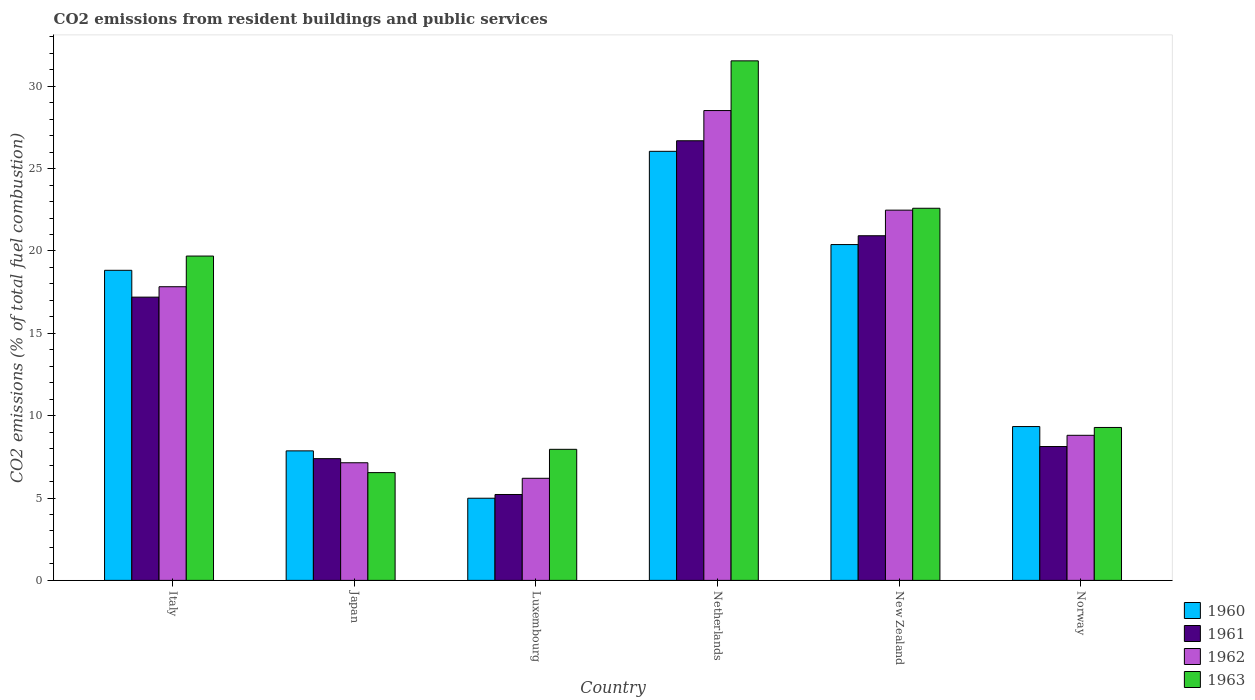How many groups of bars are there?
Provide a short and direct response. 6. Are the number of bars on each tick of the X-axis equal?
Your response must be concise. Yes. How many bars are there on the 6th tick from the left?
Make the answer very short. 4. What is the label of the 5th group of bars from the left?
Your answer should be compact. New Zealand. In how many cases, is the number of bars for a given country not equal to the number of legend labels?
Offer a terse response. 0. What is the total CO2 emitted in 1963 in Norway?
Keep it short and to the point. 9.28. Across all countries, what is the maximum total CO2 emitted in 1962?
Keep it short and to the point. 28.52. Across all countries, what is the minimum total CO2 emitted in 1960?
Provide a short and direct response. 4.99. What is the total total CO2 emitted in 1962 in the graph?
Ensure brevity in your answer.  90.98. What is the difference between the total CO2 emitted in 1962 in Netherlands and that in New Zealand?
Make the answer very short. 6.05. What is the difference between the total CO2 emitted in 1960 in Luxembourg and the total CO2 emitted in 1962 in Japan?
Provide a succinct answer. -2.15. What is the average total CO2 emitted in 1961 per country?
Provide a succinct answer. 14.26. What is the difference between the total CO2 emitted of/in 1961 and total CO2 emitted of/in 1963 in New Zealand?
Your answer should be very brief. -1.67. What is the ratio of the total CO2 emitted in 1960 in Italy to that in Japan?
Provide a succinct answer. 2.39. What is the difference between the highest and the second highest total CO2 emitted in 1960?
Offer a very short reply. 7.22. What is the difference between the highest and the lowest total CO2 emitted in 1960?
Offer a terse response. 21.06. Is it the case that in every country, the sum of the total CO2 emitted in 1961 and total CO2 emitted in 1960 is greater than the total CO2 emitted in 1962?
Give a very brief answer. Yes. How many bars are there?
Make the answer very short. 24. What is the difference between two consecutive major ticks on the Y-axis?
Your response must be concise. 5. Are the values on the major ticks of Y-axis written in scientific E-notation?
Offer a terse response. No. Where does the legend appear in the graph?
Your answer should be compact. Bottom right. How many legend labels are there?
Provide a succinct answer. 4. How are the legend labels stacked?
Your answer should be compact. Vertical. What is the title of the graph?
Keep it short and to the point. CO2 emissions from resident buildings and public services. Does "2003" appear as one of the legend labels in the graph?
Give a very brief answer. No. What is the label or title of the Y-axis?
Offer a terse response. CO2 emissions (% of total fuel combustion). What is the CO2 emissions (% of total fuel combustion) of 1960 in Italy?
Your response must be concise. 18.83. What is the CO2 emissions (% of total fuel combustion) in 1961 in Italy?
Your response must be concise. 17.2. What is the CO2 emissions (% of total fuel combustion) in 1962 in Italy?
Your answer should be very brief. 17.83. What is the CO2 emissions (% of total fuel combustion) of 1963 in Italy?
Make the answer very short. 19.69. What is the CO2 emissions (% of total fuel combustion) of 1960 in Japan?
Your answer should be very brief. 7.86. What is the CO2 emissions (% of total fuel combustion) of 1961 in Japan?
Your answer should be compact. 7.39. What is the CO2 emissions (% of total fuel combustion) of 1962 in Japan?
Make the answer very short. 7.14. What is the CO2 emissions (% of total fuel combustion) of 1963 in Japan?
Give a very brief answer. 6.54. What is the CO2 emissions (% of total fuel combustion) in 1960 in Luxembourg?
Provide a succinct answer. 4.99. What is the CO2 emissions (% of total fuel combustion) in 1961 in Luxembourg?
Provide a short and direct response. 5.21. What is the CO2 emissions (% of total fuel combustion) in 1962 in Luxembourg?
Make the answer very short. 6.2. What is the CO2 emissions (% of total fuel combustion) of 1963 in Luxembourg?
Your answer should be compact. 7.96. What is the CO2 emissions (% of total fuel combustion) of 1960 in Netherlands?
Provide a succinct answer. 26.05. What is the CO2 emissions (% of total fuel combustion) in 1961 in Netherlands?
Provide a succinct answer. 26.69. What is the CO2 emissions (% of total fuel combustion) in 1962 in Netherlands?
Offer a very short reply. 28.52. What is the CO2 emissions (% of total fuel combustion) in 1963 in Netherlands?
Make the answer very short. 31.54. What is the CO2 emissions (% of total fuel combustion) in 1960 in New Zealand?
Offer a terse response. 20.39. What is the CO2 emissions (% of total fuel combustion) in 1961 in New Zealand?
Provide a succinct answer. 20.92. What is the CO2 emissions (% of total fuel combustion) in 1962 in New Zealand?
Provide a short and direct response. 22.48. What is the CO2 emissions (% of total fuel combustion) of 1963 in New Zealand?
Offer a terse response. 22.59. What is the CO2 emissions (% of total fuel combustion) of 1960 in Norway?
Ensure brevity in your answer.  9.34. What is the CO2 emissions (% of total fuel combustion) of 1961 in Norway?
Keep it short and to the point. 8.13. What is the CO2 emissions (% of total fuel combustion) in 1962 in Norway?
Offer a terse response. 8.81. What is the CO2 emissions (% of total fuel combustion) in 1963 in Norway?
Provide a succinct answer. 9.28. Across all countries, what is the maximum CO2 emissions (% of total fuel combustion) in 1960?
Your answer should be very brief. 26.05. Across all countries, what is the maximum CO2 emissions (% of total fuel combustion) in 1961?
Provide a succinct answer. 26.69. Across all countries, what is the maximum CO2 emissions (% of total fuel combustion) of 1962?
Provide a short and direct response. 28.52. Across all countries, what is the maximum CO2 emissions (% of total fuel combustion) in 1963?
Provide a succinct answer. 31.54. Across all countries, what is the minimum CO2 emissions (% of total fuel combustion) in 1960?
Keep it short and to the point. 4.99. Across all countries, what is the minimum CO2 emissions (% of total fuel combustion) of 1961?
Provide a succinct answer. 5.21. Across all countries, what is the minimum CO2 emissions (% of total fuel combustion) in 1962?
Offer a very short reply. 6.2. Across all countries, what is the minimum CO2 emissions (% of total fuel combustion) in 1963?
Your response must be concise. 6.54. What is the total CO2 emissions (% of total fuel combustion) in 1960 in the graph?
Give a very brief answer. 87.45. What is the total CO2 emissions (% of total fuel combustion) of 1961 in the graph?
Your response must be concise. 85.54. What is the total CO2 emissions (% of total fuel combustion) in 1962 in the graph?
Offer a very short reply. 90.98. What is the total CO2 emissions (% of total fuel combustion) in 1963 in the graph?
Provide a short and direct response. 97.61. What is the difference between the CO2 emissions (% of total fuel combustion) in 1960 in Italy and that in Japan?
Make the answer very short. 10.96. What is the difference between the CO2 emissions (% of total fuel combustion) of 1961 in Italy and that in Japan?
Offer a terse response. 9.81. What is the difference between the CO2 emissions (% of total fuel combustion) of 1962 in Italy and that in Japan?
Keep it short and to the point. 10.69. What is the difference between the CO2 emissions (% of total fuel combustion) in 1963 in Italy and that in Japan?
Offer a terse response. 13.15. What is the difference between the CO2 emissions (% of total fuel combustion) of 1960 in Italy and that in Luxembourg?
Offer a terse response. 13.84. What is the difference between the CO2 emissions (% of total fuel combustion) of 1961 in Italy and that in Luxembourg?
Offer a very short reply. 11.98. What is the difference between the CO2 emissions (% of total fuel combustion) of 1962 in Italy and that in Luxembourg?
Provide a succinct answer. 11.63. What is the difference between the CO2 emissions (% of total fuel combustion) of 1963 in Italy and that in Luxembourg?
Keep it short and to the point. 11.73. What is the difference between the CO2 emissions (% of total fuel combustion) in 1960 in Italy and that in Netherlands?
Keep it short and to the point. -7.22. What is the difference between the CO2 emissions (% of total fuel combustion) in 1961 in Italy and that in Netherlands?
Make the answer very short. -9.49. What is the difference between the CO2 emissions (% of total fuel combustion) of 1962 in Italy and that in Netherlands?
Your answer should be compact. -10.7. What is the difference between the CO2 emissions (% of total fuel combustion) in 1963 in Italy and that in Netherlands?
Give a very brief answer. -11.85. What is the difference between the CO2 emissions (% of total fuel combustion) in 1960 in Italy and that in New Zealand?
Your answer should be very brief. -1.56. What is the difference between the CO2 emissions (% of total fuel combustion) in 1961 in Italy and that in New Zealand?
Make the answer very short. -3.73. What is the difference between the CO2 emissions (% of total fuel combustion) in 1962 in Italy and that in New Zealand?
Offer a very short reply. -4.65. What is the difference between the CO2 emissions (% of total fuel combustion) in 1963 in Italy and that in New Zealand?
Offer a very short reply. -2.9. What is the difference between the CO2 emissions (% of total fuel combustion) in 1960 in Italy and that in Norway?
Offer a very short reply. 9.49. What is the difference between the CO2 emissions (% of total fuel combustion) of 1961 in Italy and that in Norway?
Offer a terse response. 9.07. What is the difference between the CO2 emissions (% of total fuel combustion) of 1962 in Italy and that in Norway?
Provide a succinct answer. 9.02. What is the difference between the CO2 emissions (% of total fuel combustion) of 1963 in Italy and that in Norway?
Give a very brief answer. 10.41. What is the difference between the CO2 emissions (% of total fuel combustion) in 1960 in Japan and that in Luxembourg?
Your answer should be compact. 2.87. What is the difference between the CO2 emissions (% of total fuel combustion) in 1961 in Japan and that in Luxembourg?
Make the answer very short. 2.18. What is the difference between the CO2 emissions (% of total fuel combustion) of 1962 in Japan and that in Luxembourg?
Your response must be concise. 0.94. What is the difference between the CO2 emissions (% of total fuel combustion) in 1963 in Japan and that in Luxembourg?
Your answer should be very brief. -1.41. What is the difference between the CO2 emissions (% of total fuel combustion) in 1960 in Japan and that in Netherlands?
Give a very brief answer. -18.19. What is the difference between the CO2 emissions (% of total fuel combustion) in 1961 in Japan and that in Netherlands?
Your answer should be very brief. -19.3. What is the difference between the CO2 emissions (% of total fuel combustion) in 1962 in Japan and that in Netherlands?
Provide a short and direct response. -21.38. What is the difference between the CO2 emissions (% of total fuel combustion) of 1963 in Japan and that in Netherlands?
Your response must be concise. -25. What is the difference between the CO2 emissions (% of total fuel combustion) of 1960 in Japan and that in New Zealand?
Give a very brief answer. -12.53. What is the difference between the CO2 emissions (% of total fuel combustion) in 1961 in Japan and that in New Zealand?
Offer a terse response. -13.53. What is the difference between the CO2 emissions (% of total fuel combustion) of 1962 in Japan and that in New Zealand?
Keep it short and to the point. -15.34. What is the difference between the CO2 emissions (% of total fuel combustion) of 1963 in Japan and that in New Zealand?
Your answer should be compact. -16.05. What is the difference between the CO2 emissions (% of total fuel combustion) of 1960 in Japan and that in Norway?
Make the answer very short. -1.48. What is the difference between the CO2 emissions (% of total fuel combustion) of 1961 in Japan and that in Norway?
Your answer should be compact. -0.74. What is the difference between the CO2 emissions (% of total fuel combustion) of 1962 in Japan and that in Norway?
Give a very brief answer. -1.67. What is the difference between the CO2 emissions (% of total fuel combustion) of 1963 in Japan and that in Norway?
Provide a succinct answer. -2.74. What is the difference between the CO2 emissions (% of total fuel combustion) in 1960 in Luxembourg and that in Netherlands?
Make the answer very short. -21.06. What is the difference between the CO2 emissions (% of total fuel combustion) in 1961 in Luxembourg and that in Netherlands?
Your response must be concise. -21.48. What is the difference between the CO2 emissions (% of total fuel combustion) of 1962 in Luxembourg and that in Netherlands?
Your answer should be compact. -22.33. What is the difference between the CO2 emissions (% of total fuel combustion) of 1963 in Luxembourg and that in Netherlands?
Offer a very short reply. -23.58. What is the difference between the CO2 emissions (% of total fuel combustion) in 1960 in Luxembourg and that in New Zealand?
Make the answer very short. -15.4. What is the difference between the CO2 emissions (% of total fuel combustion) of 1961 in Luxembourg and that in New Zealand?
Your response must be concise. -15.71. What is the difference between the CO2 emissions (% of total fuel combustion) of 1962 in Luxembourg and that in New Zealand?
Provide a succinct answer. -16.28. What is the difference between the CO2 emissions (% of total fuel combustion) of 1963 in Luxembourg and that in New Zealand?
Your answer should be compact. -14.63. What is the difference between the CO2 emissions (% of total fuel combustion) in 1960 in Luxembourg and that in Norway?
Make the answer very short. -4.35. What is the difference between the CO2 emissions (% of total fuel combustion) of 1961 in Luxembourg and that in Norway?
Your answer should be very brief. -2.91. What is the difference between the CO2 emissions (% of total fuel combustion) in 1962 in Luxembourg and that in Norway?
Offer a terse response. -2.61. What is the difference between the CO2 emissions (% of total fuel combustion) of 1963 in Luxembourg and that in Norway?
Your answer should be compact. -1.33. What is the difference between the CO2 emissions (% of total fuel combustion) in 1960 in Netherlands and that in New Zealand?
Offer a very short reply. 5.66. What is the difference between the CO2 emissions (% of total fuel combustion) in 1961 in Netherlands and that in New Zealand?
Ensure brevity in your answer.  5.77. What is the difference between the CO2 emissions (% of total fuel combustion) of 1962 in Netherlands and that in New Zealand?
Your answer should be compact. 6.05. What is the difference between the CO2 emissions (% of total fuel combustion) in 1963 in Netherlands and that in New Zealand?
Offer a terse response. 8.95. What is the difference between the CO2 emissions (% of total fuel combustion) of 1960 in Netherlands and that in Norway?
Offer a terse response. 16.71. What is the difference between the CO2 emissions (% of total fuel combustion) in 1961 in Netherlands and that in Norway?
Your response must be concise. 18.56. What is the difference between the CO2 emissions (% of total fuel combustion) of 1962 in Netherlands and that in Norway?
Provide a short and direct response. 19.72. What is the difference between the CO2 emissions (% of total fuel combustion) of 1963 in Netherlands and that in Norway?
Your answer should be very brief. 22.26. What is the difference between the CO2 emissions (% of total fuel combustion) of 1960 in New Zealand and that in Norway?
Offer a terse response. 11.05. What is the difference between the CO2 emissions (% of total fuel combustion) of 1961 in New Zealand and that in Norway?
Your response must be concise. 12.8. What is the difference between the CO2 emissions (% of total fuel combustion) of 1962 in New Zealand and that in Norway?
Provide a short and direct response. 13.67. What is the difference between the CO2 emissions (% of total fuel combustion) of 1963 in New Zealand and that in Norway?
Provide a short and direct response. 13.31. What is the difference between the CO2 emissions (% of total fuel combustion) in 1960 in Italy and the CO2 emissions (% of total fuel combustion) in 1961 in Japan?
Keep it short and to the point. 11.43. What is the difference between the CO2 emissions (% of total fuel combustion) in 1960 in Italy and the CO2 emissions (% of total fuel combustion) in 1962 in Japan?
Your response must be concise. 11.68. What is the difference between the CO2 emissions (% of total fuel combustion) of 1960 in Italy and the CO2 emissions (% of total fuel combustion) of 1963 in Japan?
Your response must be concise. 12.28. What is the difference between the CO2 emissions (% of total fuel combustion) in 1961 in Italy and the CO2 emissions (% of total fuel combustion) in 1962 in Japan?
Provide a succinct answer. 10.05. What is the difference between the CO2 emissions (% of total fuel combustion) in 1961 in Italy and the CO2 emissions (% of total fuel combustion) in 1963 in Japan?
Offer a very short reply. 10.65. What is the difference between the CO2 emissions (% of total fuel combustion) in 1962 in Italy and the CO2 emissions (% of total fuel combustion) in 1963 in Japan?
Your answer should be very brief. 11.29. What is the difference between the CO2 emissions (% of total fuel combustion) in 1960 in Italy and the CO2 emissions (% of total fuel combustion) in 1961 in Luxembourg?
Keep it short and to the point. 13.61. What is the difference between the CO2 emissions (% of total fuel combustion) in 1960 in Italy and the CO2 emissions (% of total fuel combustion) in 1962 in Luxembourg?
Give a very brief answer. 12.63. What is the difference between the CO2 emissions (% of total fuel combustion) in 1960 in Italy and the CO2 emissions (% of total fuel combustion) in 1963 in Luxembourg?
Offer a terse response. 10.87. What is the difference between the CO2 emissions (% of total fuel combustion) of 1961 in Italy and the CO2 emissions (% of total fuel combustion) of 1962 in Luxembourg?
Ensure brevity in your answer.  11. What is the difference between the CO2 emissions (% of total fuel combustion) of 1961 in Italy and the CO2 emissions (% of total fuel combustion) of 1963 in Luxembourg?
Offer a very short reply. 9.24. What is the difference between the CO2 emissions (% of total fuel combustion) in 1962 in Italy and the CO2 emissions (% of total fuel combustion) in 1963 in Luxembourg?
Ensure brevity in your answer.  9.87. What is the difference between the CO2 emissions (% of total fuel combustion) of 1960 in Italy and the CO2 emissions (% of total fuel combustion) of 1961 in Netherlands?
Your answer should be very brief. -7.86. What is the difference between the CO2 emissions (% of total fuel combustion) in 1960 in Italy and the CO2 emissions (% of total fuel combustion) in 1962 in Netherlands?
Make the answer very short. -9.7. What is the difference between the CO2 emissions (% of total fuel combustion) of 1960 in Italy and the CO2 emissions (% of total fuel combustion) of 1963 in Netherlands?
Offer a terse response. -12.72. What is the difference between the CO2 emissions (% of total fuel combustion) of 1961 in Italy and the CO2 emissions (% of total fuel combustion) of 1962 in Netherlands?
Provide a short and direct response. -11.33. What is the difference between the CO2 emissions (% of total fuel combustion) of 1961 in Italy and the CO2 emissions (% of total fuel combustion) of 1963 in Netherlands?
Offer a terse response. -14.35. What is the difference between the CO2 emissions (% of total fuel combustion) in 1962 in Italy and the CO2 emissions (% of total fuel combustion) in 1963 in Netherlands?
Offer a very short reply. -13.71. What is the difference between the CO2 emissions (% of total fuel combustion) of 1960 in Italy and the CO2 emissions (% of total fuel combustion) of 1961 in New Zealand?
Your answer should be very brief. -2.1. What is the difference between the CO2 emissions (% of total fuel combustion) in 1960 in Italy and the CO2 emissions (% of total fuel combustion) in 1962 in New Zealand?
Provide a succinct answer. -3.65. What is the difference between the CO2 emissions (% of total fuel combustion) in 1960 in Italy and the CO2 emissions (% of total fuel combustion) in 1963 in New Zealand?
Offer a terse response. -3.77. What is the difference between the CO2 emissions (% of total fuel combustion) in 1961 in Italy and the CO2 emissions (% of total fuel combustion) in 1962 in New Zealand?
Your answer should be very brief. -5.28. What is the difference between the CO2 emissions (% of total fuel combustion) in 1961 in Italy and the CO2 emissions (% of total fuel combustion) in 1963 in New Zealand?
Offer a very short reply. -5.4. What is the difference between the CO2 emissions (% of total fuel combustion) in 1962 in Italy and the CO2 emissions (% of total fuel combustion) in 1963 in New Zealand?
Keep it short and to the point. -4.76. What is the difference between the CO2 emissions (% of total fuel combustion) of 1960 in Italy and the CO2 emissions (% of total fuel combustion) of 1961 in Norway?
Your answer should be very brief. 10.7. What is the difference between the CO2 emissions (% of total fuel combustion) in 1960 in Italy and the CO2 emissions (% of total fuel combustion) in 1962 in Norway?
Provide a succinct answer. 10.02. What is the difference between the CO2 emissions (% of total fuel combustion) of 1960 in Italy and the CO2 emissions (% of total fuel combustion) of 1963 in Norway?
Offer a terse response. 9.54. What is the difference between the CO2 emissions (% of total fuel combustion) in 1961 in Italy and the CO2 emissions (% of total fuel combustion) in 1962 in Norway?
Provide a succinct answer. 8.39. What is the difference between the CO2 emissions (% of total fuel combustion) of 1961 in Italy and the CO2 emissions (% of total fuel combustion) of 1963 in Norway?
Provide a short and direct response. 7.91. What is the difference between the CO2 emissions (% of total fuel combustion) of 1962 in Italy and the CO2 emissions (% of total fuel combustion) of 1963 in Norway?
Your answer should be compact. 8.54. What is the difference between the CO2 emissions (% of total fuel combustion) of 1960 in Japan and the CO2 emissions (% of total fuel combustion) of 1961 in Luxembourg?
Your answer should be very brief. 2.65. What is the difference between the CO2 emissions (% of total fuel combustion) of 1960 in Japan and the CO2 emissions (% of total fuel combustion) of 1962 in Luxembourg?
Your answer should be very brief. 1.66. What is the difference between the CO2 emissions (% of total fuel combustion) of 1960 in Japan and the CO2 emissions (% of total fuel combustion) of 1963 in Luxembourg?
Your response must be concise. -0.09. What is the difference between the CO2 emissions (% of total fuel combustion) of 1961 in Japan and the CO2 emissions (% of total fuel combustion) of 1962 in Luxembourg?
Your response must be concise. 1.19. What is the difference between the CO2 emissions (% of total fuel combustion) in 1961 in Japan and the CO2 emissions (% of total fuel combustion) in 1963 in Luxembourg?
Make the answer very short. -0.57. What is the difference between the CO2 emissions (% of total fuel combustion) of 1962 in Japan and the CO2 emissions (% of total fuel combustion) of 1963 in Luxembourg?
Keep it short and to the point. -0.82. What is the difference between the CO2 emissions (% of total fuel combustion) in 1960 in Japan and the CO2 emissions (% of total fuel combustion) in 1961 in Netherlands?
Offer a very short reply. -18.83. What is the difference between the CO2 emissions (% of total fuel combustion) of 1960 in Japan and the CO2 emissions (% of total fuel combustion) of 1962 in Netherlands?
Keep it short and to the point. -20.66. What is the difference between the CO2 emissions (% of total fuel combustion) in 1960 in Japan and the CO2 emissions (% of total fuel combustion) in 1963 in Netherlands?
Provide a succinct answer. -23.68. What is the difference between the CO2 emissions (% of total fuel combustion) in 1961 in Japan and the CO2 emissions (% of total fuel combustion) in 1962 in Netherlands?
Make the answer very short. -21.13. What is the difference between the CO2 emissions (% of total fuel combustion) in 1961 in Japan and the CO2 emissions (% of total fuel combustion) in 1963 in Netherlands?
Your answer should be compact. -24.15. What is the difference between the CO2 emissions (% of total fuel combustion) in 1962 in Japan and the CO2 emissions (% of total fuel combustion) in 1963 in Netherlands?
Your response must be concise. -24.4. What is the difference between the CO2 emissions (% of total fuel combustion) in 1960 in Japan and the CO2 emissions (% of total fuel combustion) in 1961 in New Zealand?
Offer a terse response. -13.06. What is the difference between the CO2 emissions (% of total fuel combustion) of 1960 in Japan and the CO2 emissions (% of total fuel combustion) of 1962 in New Zealand?
Your answer should be compact. -14.61. What is the difference between the CO2 emissions (% of total fuel combustion) of 1960 in Japan and the CO2 emissions (% of total fuel combustion) of 1963 in New Zealand?
Provide a succinct answer. -14.73. What is the difference between the CO2 emissions (% of total fuel combustion) of 1961 in Japan and the CO2 emissions (% of total fuel combustion) of 1962 in New Zealand?
Give a very brief answer. -15.09. What is the difference between the CO2 emissions (% of total fuel combustion) of 1961 in Japan and the CO2 emissions (% of total fuel combustion) of 1963 in New Zealand?
Provide a short and direct response. -15.2. What is the difference between the CO2 emissions (% of total fuel combustion) of 1962 in Japan and the CO2 emissions (% of total fuel combustion) of 1963 in New Zealand?
Keep it short and to the point. -15.45. What is the difference between the CO2 emissions (% of total fuel combustion) in 1960 in Japan and the CO2 emissions (% of total fuel combustion) in 1961 in Norway?
Your answer should be compact. -0.26. What is the difference between the CO2 emissions (% of total fuel combustion) in 1960 in Japan and the CO2 emissions (% of total fuel combustion) in 1962 in Norway?
Provide a succinct answer. -0.94. What is the difference between the CO2 emissions (% of total fuel combustion) of 1960 in Japan and the CO2 emissions (% of total fuel combustion) of 1963 in Norway?
Make the answer very short. -1.42. What is the difference between the CO2 emissions (% of total fuel combustion) of 1961 in Japan and the CO2 emissions (% of total fuel combustion) of 1962 in Norway?
Ensure brevity in your answer.  -1.42. What is the difference between the CO2 emissions (% of total fuel combustion) of 1961 in Japan and the CO2 emissions (% of total fuel combustion) of 1963 in Norway?
Keep it short and to the point. -1.89. What is the difference between the CO2 emissions (% of total fuel combustion) of 1962 in Japan and the CO2 emissions (% of total fuel combustion) of 1963 in Norway?
Provide a short and direct response. -2.14. What is the difference between the CO2 emissions (% of total fuel combustion) in 1960 in Luxembourg and the CO2 emissions (% of total fuel combustion) in 1961 in Netherlands?
Provide a succinct answer. -21.7. What is the difference between the CO2 emissions (% of total fuel combustion) of 1960 in Luxembourg and the CO2 emissions (% of total fuel combustion) of 1962 in Netherlands?
Offer a very short reply. -23.54. What is the difference between the CO2 emissions (% of total fuel combustion) of 1960 in Luxembourg and the CO2 emissions (% of total fuel combustion) of 1963 in Netherlands?
Offer a terse response. -26.55. What is the difference between the CO2 emissions (% of total fuel combustion) in 1961 in Luxembourg and the CO2 emissions (% of total fuel combustion) in 1962 in Netherlands?
Your answer should be very brief. -23.31. What is the difference between the CO2 emissions (% of total fuel combustion) of 1961 in Luxembourg and the CO2 emissions (% of total fuel combustion) of 1963 in Netherlands?
Ensure brevity in your answer.  -26.33. What is the difference between the CO2 emissions (% of total fuel combustion) in 1962 in Luxembourg and the CO2 emissions (% of total fuel combustion) in 1963 in Netherlands?
Give a very brief answer. -25.34. What is the difference between the CO2 emissions (% of total fuel combustion) of 1960 in Luxembourg and the CO2 emissions (% of total fuel combustion) of 1961 in New Zealand?
Offer a terse response. -15.94. What is the difference between the CO2 emissions (% of total fuel combustion) in 1960 in Luxembourg and the CO2 emissions (% of total fuel combustion) in 1962 in New Zealand?
Your answer should be very brief. -17.49. What is the difference between the CO2 emissions (% of total fuel combustion) of 1960 in Luxembourg and the CO2 emissions (% of total fuel combustion) of 1963 in New Zealand?
Your response must be concise. -17.6. What is the difference between the CO2 emissions (% of total fuel combustion) of 1961 in Luxembourg and the CO2 emissions (% of total fuel combustion) of 1962 in New Zealand?
Offer a very short reply. -17.26. What is the difference between the CO2 emissions (% of total fuel combustion) of 1961 in Luxembourg and the CO2 emissions (% of total fuel combustion) of 1963 in New Zealand?
Make the answer very short. -17.38. What is the difference between the CO2 emissions (% of total fuel combustion) in 1962 in Luxembourg and the CO2 emissions (% of total fuel combustion) in 1963 in New Zealand?
Keep it short and to the point. -16.39. What is the difference between the CO2 emissions (% of total fuel combustion) of 1960 in Luxembourg and the CO2 emissions (% of total fuel combustion) of 1961 in Norway?
Provide a short and direct response. -3.14. What is the difference between the CO2 emissions (% of total fuel combustion) of 1960 in Luxembourg and the CO2 emissions (% of total fuel combustion) of 1962 in Norway?
Ensure brevity in your answer.  -3.82. What is the difference between the CO2 emissions (% of total fuel combustion) in 1960 in Luxembourg and the CO2 emissions (% of total fuel combustion) in 1963 in Norway?
Ensure brevity in your answer.  -4.3. What is the difference between the CO2 emissions (% of total fuel combustion) in 1961 in Luxembourg and the CO2 emissions (% of total fuel combustion) in 1962 in Norway?
Offer a very short reply. -3.59. What is the difference between the CO2 emissions (% of total fuel combustion) of 1961 in Luxembourg and the CO2 emissions (% of total fuel combustion) of 1963 in Norway?
Your answer should be compact. -4.07. What is the difference between the CO2 emissions (% of total fuel combustion) in 1962 in Luxembourg and the CO2 emissions (% of total fuel combustion) in 1963 in Norway?
Ensure brevity in your answer.  -3.09. What is the difference between the CO2 emissions (% of total fuel combustion) in 1960 in Netherlands and the CO2 emissions (% of total fuel combustion) in 1961 in New Zealand?
Your response must be concise. 5.13. What is the difference between the CO2 emissions (% of total fuel combustion) in 1960 in Netherlands and the CO2 emissions (% of total fuel combustion) in 1962 in New Zealand?
Offer a terse response. 3.57. What is the difference between the CO2 emissions (% of total fuel combustion) of 1960 in Netherlands and the CO2 emissions (% of total fuel combustion) of 1963 in New Zealand?
Provide a short and direct response. 3.46. What is the difference between the CO2 emissions (% of total fuel combustion) of 1961 in Netherlands and the CO2 emissions (% of total fuel combustion) of 1962 in New Zealand?
Give a very brief answer. 4.21. What is the difference between the CO2 emissions (% of total fuel combustion) in 1961 in Netherlands and the CO2 emissions (% of total fuel combustion) in 1963 in New Zealand?
Provide a short and direct response. 4.1. What is the difference between the CO2 emissions (% of total fuel combustion) in 1962 in Netherlands and the CO2 emissions (% of total fuel combustion) in 1963 in New Zealand?
Ensure brevity in your answer.  5.93. What is the difference between the CO2 emissions (% of total fuel combustion) of 1960 in Netherlands and the CO2 emissions (% of total fuel combustion) of 1961 in Norway?
Your response must be concise. 17.92. What is the difference between the CO2 emissions (% of total fuel combustion) of 1960 in Netherlands and the CO2 emissions (% of total fuel combustion) of 1962 in Norway?
Offer a terse response. 17.24. What is the difference between the CO2 emissions (% of total fuel combustion) in 1960 in Netherlands and the CO2 emissions (% of total fuel combustion) in 1963 in Norway?
Offer a terse response. 16.76. What is the difference between the CO2 emissions (% of total fuel combustion) in 1961 in Netherlands and the CO2 emissions (% of total fuel combustion) in 1962 in Norway?
Give a very brief answer. 17.88. What is the difference between the CO2 emissions (% of total fuel combustion) of 1961 in Netherlands and the CO2 emissions (% of total fuel combustion) of 1963 in Norway?
Your answer should be compact. 17.41. What is the difference between the CO2 emissions (% of total fuel combustion) in 1962 in Netherlands and the CO2 emissions (% of total fuel combustion) in 1963 in Norway?
Offer a very short reply. 19.24. What is the difference between the CO2 emissions (% of total fuel combustion) of 1960 in New Zealand and the CO2 emissions (% of total fuel combustion) of 1961 in Norway?
Keep it short and to the point. 12.26. What is the difference between the CO2 emissions (% of total fuel combustion) in 1960 in New Zealand and the CO2 emissions (% of total fuel combustion) in 1962 in Norway?
Provide a short and direct response. 11.58. What is the difference between the CO2 emissions (% of total fuel combustion) in 1960 in New Zealand and the CO2 emissions (% of total fuel combustion) in 1963 in Norway?
Your answer should be very brief. 11.1. What is the difference between the CO2 emissions (% of total fuel combustion) in 1961 in New Zealand and the CO2 emissions (% of total fuel combustion) in 1962 in Norway?
Offer a very short reply. 12.12. What is the difference between the CO2 emissions (% of total fuel combustion) of 1961 in New Zealand and the CO2 emissions (% of total fuel combustion) of 1963 in Norway?
Your answer should be very brief. 11.64. What is the difference between the CO2 emissions (% of total fuel combustion) of 1962 in New Zealand and the CO2 emissions (% of total fuel combustion) of 1963 in Norway?
Keep it short and to the point. 13.19. What is the average CO2 emissions (% of total fuel combustion) of 1960 per country?
Make the answer very short. 14.58. What is the average CO2 emissions (% of total fuel combustion) of 1961 per country?
Your response must be concise. 14.26. What is the average CO2 emissions (% of total fuel combustion) of 1962 per country?
Provide a short and direct response. 15.16. What is the average CO2 emissions (% of total fuel combustion) in 1963 per country?
Offer a very short reply. 16.27. What is the difference between the CO2 emissions (% of total fuel combustion) in 1960 and CO2 emissions (% of total fuel combustion) in 1961 in Italy?
Your answer should be very brief. 1.63. What is the difference between the CO2 emissions (% of total fuel combustion) of 1960 and CO2 emissions (% of total fuel combustion) of 1962 in Italy?
Provide a succinct answer. 1. What is the difference between the CO2 emissions (% of total fuel combustion) in 1960 and CO2 emissions (% of total fuel combustion) in 1963 in Italy?
Give a very brief answer. -0.87. What is the difference between the CO2 emissions (% of total fuel combustion) of 1961 and CO2 emissions (% of total fuel combustion) of 1962 in Italy?
Your response must be concise. -0.63. What is the difference between the CO2 emissions (% of total fuel combustion) in 1961 and CO2 emissions (% of total fuel combustion) in 1963 in Italy?
Ensure brevity in your answer.  -2.49. What is the difference between the CO2 emissions (% of total fuel combustion) in 1962 and CO2 emissions (% of total fuel combustion) in 1963 in Italy?
Offer a terse response. -1.86. What is the difference between the CO2 emissions (% of total fuel combustion) of 1960 and CO2 emissions (% of total fuel combustion) of 1961 in Japan?
Keep it short and to the point. 0.47. What is the difference between the CO2 emissions (% of total fuel combustion) in 1960 and CO2 emissions (% of total fuel combustion) in 1962 in Japan?
Give a very brief answer. 0.72. What is the difference between the CO2 emissions (% of total fuel combustion) in 1960 and CO2 emissions (% of total fuel combustion) in 1963 in Japan?
Give a very brief answer. 1.32. What is the difference between the CO2 emissions (% of total fuel combustion) in 1961 and CO2 emissions (% of total fuel combustion) in 1962 in Japan?
Your response must be concise. 0.25. What is the difference between the CO2 emissions (% of total fuel combustion) in 1961 and CO2 emissions (% of total fuel combustion) in 1963 in Japan?
Your response must be concise. 0.85. What is the difference between the CO2 emissions (% of total fuel combustion) of 1962 and CO2 emissions (% of total fuel combustion) of 1963 in Japan?
Keep it short and to the point. 0.6. What is the difference between the CO2 emissions (% of total fuel combustion) of 1960 and CO2 emissions (% of total fuel combustion) of 1961 in Luxembourg?
Keep it short and to the point. -0.23. What is the difference between the CO2 emissions (% of total fuel combustion) of 1960 and CO2 emissions (% of total fuel combustion) of 1962 in Luxembourg?
Provide a short and direct response. -1.21. What is the difference between the CO2 emissions (% of total fuel combustion) in 1960 and CO2 emissions (% of total fuel combustion) in 1963 in Luxembourg?
Ensure brevity in your answer.  -2.97. What is the difference between the CO2 emissions (% of total fuel combustion) in 1961 and CO2 emissions (% of total fuel combustion) in 1962 in Luxembourg?
Provide a short and direct response. -0.98. What is the difference between the CO2 emissions (% of total fuel combustion) in 1961 and CO2 emissions (% of total fuel combustion) in 1963 in Luxembourg?
Provide a short and direct response. -2.74. What is the difference between the CO2 emissions (% of total fuel combustion) of 1962 and CO2 emissions (% of total fuel combustion) of 1963 in Luxembourg?
Offer a very short reply. -1.76. What is the difference between the CO2 emissions (% of total fuel combustion) of 1960 and CO2 emissions (% of total fuel combustion) of 1961 in Netherlands?
Your response must be concise. -0.64. What is the difference between the CO2 emissions (% of total fuel combustion) of 1960 and CO2 emissions (% of total fuel combustion) of 1962 in Netherlands?
Your answer should be very brief. -2.47. What is the difference between the CO2 emissions (% of total fuel combustion) of 1960 and CO2 emissions (% of total fuel combustion) of 1963 in Netherlands?
Make the answer very short. -5.49. What is the difference between the CO2 emissions (% of total fuel combustion) in 1961 and CO2 emissions (% of total fuel combustion) in 1962 in Netherlands?
Give a very brief answer. -1.83. What is the difference between the CO2 emissions (% of total fuel combustion) of 1961 and CO2 emissions (% of total fuel combustion) of 1963 in Netherlands?
Your response must be concise. -4.85. What is the difference between the CO2 emissions (% of total fuel combustion) of 1962 and CO2 emissions (% of total fuel combustion) of 1963 in Netherlands?
Your answer should be very brief. -3.02. What is the difference between the CO2 emissions (% of total fuel combustion) in 1960 and CO2 emissions (% of total fuel combustion) in 1961 in New Zealand?
Give a very brief answer. -0.54. What is the difference between the CO2 emissions (% of total fuel combustion) in 1960 and CO2 emissions (% of total fuel combustion) in 1962 in New Zealand?
Your answer should be very brief. -2.09. What is the difference between the CO2 emissions (% of total fuel combustion) in 1960 and CO2 emissions (% of total fuel combustion) in 1963 in New Zealand?
Keep it short and to the point. -2.2. What is the difference between the CO2 emissions (% of total fuel combustion) of 1961 and CO2 emissions (% of total fuel combustion) of 1962 in New Zealand?
Give a very brief answer. -1.55. What is the difference between the CO2 emissions (% of total fuel combustion) of 1961 and CO2 emissions (% of total fuel combustion) of 1963 in New Zealand?
Ensure brevity in your answer.  -1.67. What is the difference between the CO2 emissions (% of total fuel combustion) of 1962 and CO2 emissions (% of total fuel combustion) of 1963 in New Zealand?
Give a very brief answer. -0.12. What is the difference between the CO2 emissions (% of total fuel combustion) in 1960 and CO2 emissions (% of total fuel combustion) in 1961 in Norway?
Your answer should be compact. 1.21. What is the difference between the CO2 emissions (% of total fuel combustion) in 1960 and CO2 emissions (% of total fuel combustion) in 1962 in Norway?
Your response must be concise. 0.53. What is the difference between the CO2 emissions (% of total fuel combustion) of 1960 and CO2 emissions (% of total fuel combustion) of 1963 in Norway?
Your response must be concise. 0.05. What is the difference between the CO2 emissions (% of total fuel combustion) in 1961 and CO2 emissions (% of total fuel combustion) in 1962 in Norway?
Your answer should be compact. -0.68. What is the difference between the CO2 emissions (% of total fuel combustion) in 1961 and CO2 emissions (% of total fuel combustion) in 1963 in Norway?
Your answer should be very brief. -1.16. What is the difference between the CO2 emissions (% of total fuel combustion) of 1962 and CO2 emissions (% of total fuel combustion) of 1963 in Norway?
Provide a succinct answer. -0.48. What is the ratio of the CO2 emissions (% of total fuel combustion) of 1960 in Italy to that in Japan?
Offer a very short reply. 2.39. What is the ratio of the CO2 emissions (% of total fuel combustion) of 1961 in Italy to that in Japan?
Provide a short and direct response. 2.33. What is the ratio of the CO2 emissions (% of total fuel combustion) of 1962 in Italy to that in Japan?
Give a very brief answer. 2.5. What is the ratio of the CO2 emissions (% of total fuel combustion) of 1963 in Italy to that in Japan?
Provide a short and direct response. 3.01. What is the ratio of the CO2 emissions (% of total fuel combustion) in 1960 in Italy to that in Luxembourg?
Ensure brevity in your answer.  3.77. What is the ratio of the CO2 emissions (% of total fuel combustion) in 1961 in Italy to that in Luxembourg?
Your answer should be compact. 3.3. What is the ratio of the CO2 emissions (% of total fuel combustion) in 1962 in Italy to that in Luxembourg?
Your answer should be very brief. 2.88. What is the ratio of the CO2 emissions (% of total fuel combustion) of 1963 in Italy to that in Luxembourg?
Your answer should be compact. 2.47. What is the ratio of the CO2 emissions (% of total fuel combustion) of 1960 in Italy to that in Netherlands?
Your answer should be very brief. 0.72. What is the ratio of the CO2 emissions (% of total fuel combustion) of 1961 in Italy to that in Netherlands?
Offer a terse response. 0.64. What is the ratio of the CO2 emissions (% of total fuel combustion) of 1963 in Italy to that in Netherlands?
Provide a succinct answer. 0.62. What is the ratio of the CO2 emissions (% of total fuel combustion) in 1960 in Italy to that in New Zealand?
Make the answer very short. 0.92. What is the ratio of the CO2 emissions (% of total fuel combustion) of 1961 in Italy to that in New Zealand?
Ensure brevity in your answer.  0.82. What is the ratio of the CO2 emissions (% of total fuel combustion) of 1962 in Italy to that in New Zealand?
Ensure brevity in your answer.  0.79. What is the ratio of the CO2 emissions (% of total fuel combustion) of 1963 in Italy to that in New Zealand?
Offer a very short reply. 0.87. What is the ratio of the CO2 emissions (% of total fuel combustion) of 1960 in Italy to that in Norway?
Make the answer very short. 2.02. What is the ratio of the CO2 emissions (% of total fuel combustion) of 1961 in Italy to that in Norway?
Offer a very short reply. 2.12. What is the ratio of the CO2 emissions (% of total fuel combustion) in 1962 in Italy to that in Norway?
Keep it short and to the point. 2.02. What is the ratio of the CO2 emissions (% of total fuel combustion) in 1963 in Italy to that in Norway?
Your response must be concise. 2.12. What is the ratio of the CO2 emissions (% of total fuel combustion) of 1960 in Japan to that in Luxembourg?
Your answer should be very brief. 1.58. What is the ratio of the CO2 emissions (% of total fuel combustion) in 1961 in Japan to that in Luxembourg?
Make the answer very short. 1.42. What is the ratio of the CO2 emissions (% of total fuel combustion) in 1962 in Japan to that in Luxembourg?
Keep it short and to the point. 1.15. What is the ratio of the CO2 emissions (% of total fuel combustion) in 1963 in Japan to that in Luxembourg?
Give a very brief answer. 0.82. What is the ratio of the CO2 emissions (% of total fuel combustion) of 1960 in Japan to that in Netherlands?
Your answer should be compact. 0.3. What is the ratio of the CO2 emissions (% of total fuel combustion) of 1961 in Japan to that in Netherlands?
Your response must be concise. 0.28. What is the ratio of the CO2 emissions (% of total fuel combustion) in 1962 in Japan to that in Netherlands?
Ensure brevity in your answer.  0.25. What is the ratio of the CO2 emissions (% of total fuel combustion) of 1963 in Japan to that in Netherlands?
Your response must be concise. 0.21. What is the ratio of the CO2 emissions (% of total fuel combustion) in 1960 in Japan to that in New Zealand?
Your response must be concise. 0.39. What is the ratio of the CO2 emissions (% of total fuel combustion) of 1961 in Japan to that in New Zealand?
Offer a very short reply. 0.35. What is the ratio of the CO2 emissions (% of total fuel combustion) of 1962 in Japan to that in New Zealand?
Your answer should be compact. 0.32. What is the ratio of the CO2 emissions (% of total fuel combustion) of 1963 in Japan to that in New Zealand?
Your answer should be very brief. 0.29. What is the ratio of the CO2 emissions (% of total fuel combustion) in 1960 in Japan to that in Norway?
Keep it short and to the point. 0.84. What is the ratio of the CO2 emissions (% of total fuel combustion) of 1961 in Japan to that in Norway?
Offer a very short reply. 0.91. What is the ratio of the CO2 emissions (% of total fuel combustion) of 1962 in Japan to that in Norway?
Your answer should be compact. 0.81. What is the ratio of the CO2 emissions (% of total fuel combustion) of 1963 in Japan to that in Norway?
Your answer should be compact. 0.7. What is the ratio of the CO2 emissions (% of total fuel combustion) in 1960 in Luxembourg to that in Netherlands?
Make the answer very short. 0.19. What is the ratio of the CO2 emissions (% of total fuel combustion) in 1961 in Luxembourg to that in Netherlands?
Give a very brief answer. 0.2. What is the ratio of the CO2 emissions (% of total fuel combustion) of 1962 in Luxembourg to that in Netherlands?
Keep it short and to the point. 0.22. What is the ratio of the CO2 emissions (% of total fuel combustion) in 1963 in Luxembourg to that in Netherlands?
Your answer should be compact. 0.25. What is the ratio of the CO2 emissions (% of total fuel combustion) of 1960 in Luxembourg to that in New Zealand?
Your answer should be compact. 0.24. What is the ratio of the CO2 emissions (% of total fuel combustion) in 1961 in Luxembourg to that in New Zealand?
Keep it short and to the point. 0.25. What is the ratio of the CO2 emissions (% of total fuel combustion) of 1962 in Luxembourg to that in New Zealand?
Make the answer very short. 0.28. What is the ratio of the CO2 emissions (% of total fuel combustion) of 1963 in Luxembourg to that in New Zealand?
Ensure brevity in your answer.  0.35. What is the ratio of the CO2 emissions (% of total fuel combustion) in 1960 in Luxembourg to that in Norway?
Your answer should be compact. 0.53. What is the ratio of the CO2 emissions (% of total fuel combustion) in 1961 in Luxembourg to that in Norway?
Your answer should be compact. 0.64. What is the ratio of the CO2 emissions (% of total fuel combustion) in 1962 in Luxembourg to that in Norway?
Keep it short and to the point. 0.7. What is the ratio of the CO2 emissions (% of total fuel combustion) of 1960 in Netherlands to that in New Zealand?
Provide a succinct answer. 1.28. What is the ratio of the CO2 emissions (% of total fuel combustion) in 1961 in Netherlands to that in New Zealand?
Give a very brief answer. 1.28. What is the ratio of the CO2 emissions (% of total fuel combustion) of 1962 in Netherlands to that in New Zealand?
Your answer should be very brief. 1.27. What is the ratio of the CO2 emissions (% of total fuel combustion) in 1963 in Netherlands to that in New Zealand?
Your response must be concise. 1.4. What is the ratio of the CO2 emissions (% of total fuel combustion) in 1960 in Netherlands to that in Norway?
Keep it short and to the point. 2.79. What is the ratio of the CO2 emissions (% of total fuel combustion) in 1961 in Netherlands to that in Norway?
Your response must be concise. 3.28. What is the ratio of the CO2 emissions (% of total fuel combustion) in 1962 in Netherlands to that in Norway?
Give a very brief answer. 3.24. What is the ratio of the CO2 emissions (% of total fuel combustion) in 1963 in Netherlands to that in Norway?
Your answer should be very brief. 3.4. What is the ratio of the CO2 emissions (% of total fuel combustion) in 1960 in New Zealand to that in Norway?
Your answer should be very brief. 2.18. What is the ratio of the CO2 emissions (% of total fuel combustion) in 1961 in New Zealand to that in Norway?
Your answer should be very brief. 2.57. What is the ratio of the CO2 emissions (% of total fuel combustion) in 1962 in New Zealand to that in Norway?
Provide a succinct answer. 2.55. What is the ratio of the CO2 emissions (% of total fuel combustion) of 1963 in New Zealand to that in Norway?
Give a very brief answer. 2.43. What is the difference between the highest and the second highest CO2 emissions (% of total fuel combustion) in 1960?
Provide a succinct answer. 5.66. What is the difference between the highest and the second highest CO2 emissions (% of total fuel combustion) of 1961?
Offer a terse response. 5.77. What is the difference between the highest and the second highest CO2 emissions (% of total fuel combustion) in 1962?
Make the answer very short. 6.05. What is the difference between the highest and the second highest CO2 emissions (% of total fuel combustion) of 1963?
Your answer should be very brief. 8.95. What is the difference between the highest and the lowest CO2 emissions (% of total fuel combustion) in 1960?
Your answer should be very brief. 21.06. What is the difference between the highest and the lowest CO2 emissions (% of total fuel combustion) in 1961?
Keep it short and to the point. 21.48. What is the difference between the highest and the lowest CO2 emissions (% of total fuel combustion) of 1962?
Ensure brevity in your answer.  22.33. What is the difference between the highest and the lowest CO2 emissions (% of total fuel combustion) of 1963?
Your answer should be compact. 25. 